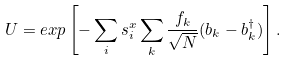<formula> <loc_0><loc_0><loc_500><loc_500>U = e x p \left [ - \sum _ { i } s _ { i } ^ { x } \sum _ { k } \frac { f _ { k } } { \sqrt { N } } ( b _ { k } - b ^ { \dagger } _ { k } ) \right ] .</formula> 